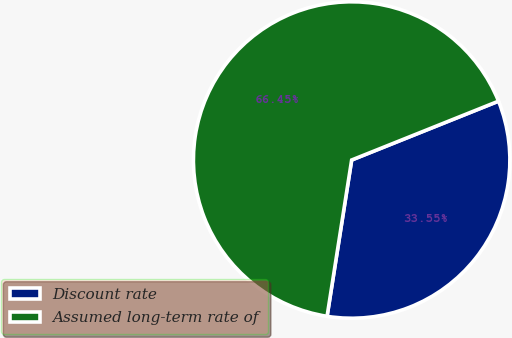Convert chart. <chart><loc_0><loc_0><loc_500><loc_500><pie_chart><fcel>Discount rate<fcel>Assumed long-term rate of<nl><fcel>33.55%<fcel>66.45%<nl></chart> 